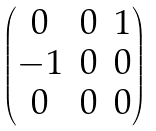<formula> <loc_0><loc_0><loc_500><loc_500>\begin{pmatrix} 0 & 0 & 1 \\ - 1 & 0 & 0 \\ 0 & 0 & 0 \end{pmatrix}</formula> 